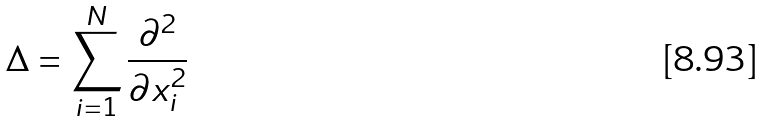Convert formula to latex. <formula><loc_0><loc_0><loc_500><loc_500>\Delta = \sum ^ { N } _ { i = 1 } \frac { \partial ^ { 2 } } { \partial x ^ { 2 } _ { i } }</formula> 